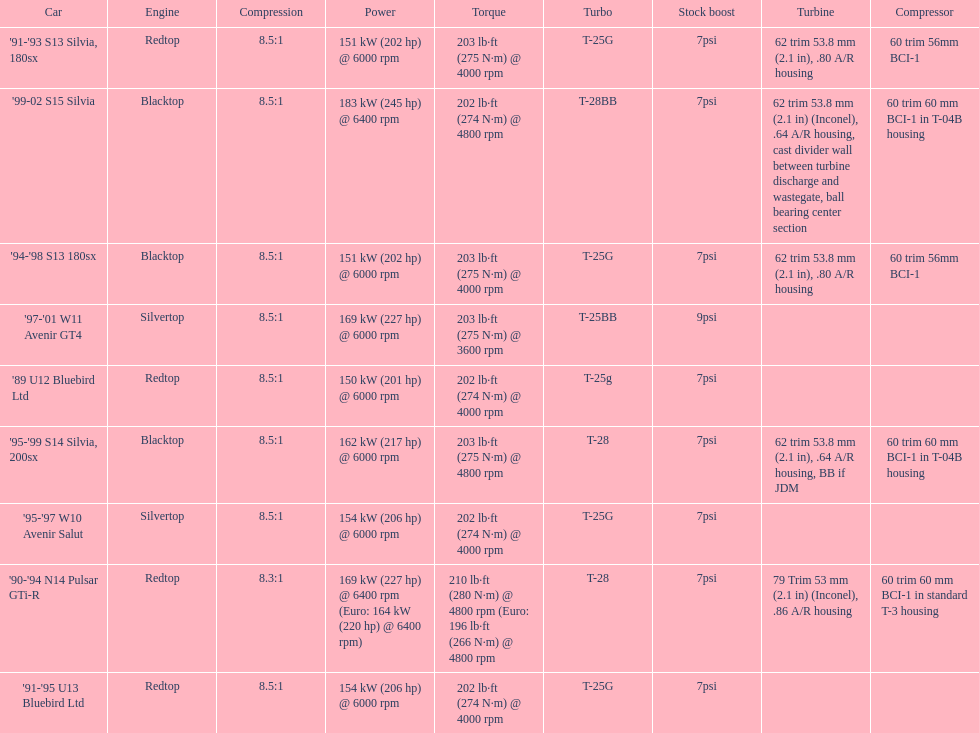Which car is the only one with more than 230 hp? '99-02 S15 Silvia. Can you give me this table as a dict? {'header': ['Car', 'Engine', 'Compression', 'Power', 'Torque', 'Turbo', 'Stock boost', 'Turbine', 'Compressor'], 'rows': [["'91-'93 S13 Silvia, 180sx", 'Redtop', '8.5:1', '151\xa0kW (202\xa0hp) @ 6000 rpm', '203\xa0lb·ft (275\xa0N·m) @ 4000 rpm', 'T-25G', '7psi', '62 trim 53.8\xa0mm (2.1\xa0in), .80 A/R housing', '60 trim 56mm BCI-1'], ["'99-02 S15 Silvia", 'Blacktop', '8.5:1', '183\xa0kW (245\xa0hp) @ 6400 rpm', '202\xa0lb·ft (274\xa0N·m) @ 4800 rpm', 'T-28BB', '7psi', '62 trim 53.8\xa0mm (2.1\xa0in) (Inconel), .64 A/R housing, cast divider wall between turbine discharge and wastegate, ball bearing center section', '60 trim 60\xa0mm BCI-1 in T-04B housing'], ["'94-'98 S13 180sx", 'Blacktop', '8.5:1', '151\xa0kW (202\xa0hp) @ 6000 rpm', '203\xa0lb·ft (275\xa0N·m) @ 4000 rpm', 'T-25G', '7psi', '62 trim 53.8\xa0mm (2.1\xa0in), .80 A/R housing', '60 trim 56mm BCI-1'], ["'97-'01 W11 Avenir GT4", 'Silvertop', '8.5:1', '169\xa0kW (227\xa0hp) @ 6000 rpm', '203\xa0lb·ft (275\xa0N·m) @ 3600 rpm', 'T-25BB', '9psi', '', ''], ["'89 U12 Bluebird Ltd", 'Redtop', '8.5:1', '150\xa0kW (201\xa0hp) @ 6000 rpm', '202\xa0lb·ft (274\xa0N·m) @ 4000 rpm', 'T-25g', '7psi', '', ''], ["'95-'99 S14 Silvia, 200sx", 'Blacktop', '8.5:1', '162\xa0kW (217\xa0hp) @ 6000 rpm', '203\xa0lb·ft (275\xa0N·m) @ 4800 rpm', 'T-28', '7psi', '62 trim 53.8\xa0mm (2.1\xa0in), .64 A/R housing, BB if JDM', '60 trim 60\xa0mm BCI-1 in T-04B housing'], ["'95-'97 W10 Avenir Salut", 'Silvertop', '8.5:1', '154\xa0kW (206\xa0hp) @ 6000 rpm', '202\xa0lb·ft (274\xa0N·m) @ 4000 rpm', 'T-25G', '7psi', '', ''], ["'90-'94 N14 Pulsar GTi-R", 'Redtop', '8.3:1', '169\xa0kW (227\xa0hp) @ 6400 rpm (Euro: 164\xa0kW (220\xa0hp) @ 6400 rpm)', '210\xa0lb·ft (280\xa0N·m) @ 4800 rpm (Euro: 196\xa0lb·ft (266\xa0N·m) @ 4800 rpm', 'T-28', '7psi', '79 Trim 53\xa0mm (2.1\xa0in) (Inconel), .86 A/R housing', '60 trim 60\xa0mm BCI-1 in standard T-3 housing'], ["'91-'95 U13 Bluebird Ltd", 'Redtop', '8.5:1', '154\xa0kW (206\xa0hp) @ 6000 rpm', '202\xa0lb·ft (274\xa0N·m) @ 4000 rpm', 'T-25G', '7psi', '', '']]} 